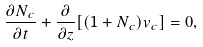Convert formula to latex. <formula><loc_0><loc_0><loc_500><loc_500>\frac { \partial N _ { c } } { \partial t } + \frac { \partial } { \partial z } [ ( 1 + N _ { c } ) v _ { c } ] = 0 ,</formula> 